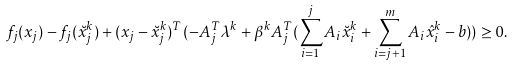<formula> <loc_0><loc_0><loc_500><loc_500>& f _ { j } ( x _ { j } ) - f _ { j } ( \breve { x } _ { j } ^ { k } ) + ( x _ { j } - \breve { x } ^ { k } _ { j } ) ^ { T } ( - A _ { j } ^ { T } \lambda ^ { k } + \beta ^ { k } A _ { j } ^ { T } ( \sum _ { i = 1 } ^ { j } A _ { i } \breve { x } _ { i } ^ { k } + \sum _ { i = j + 1 } ^ { m } A _ { i } \hat { x } _ { i } ^ { k } - b ) ) \geq 0 .</formula> 